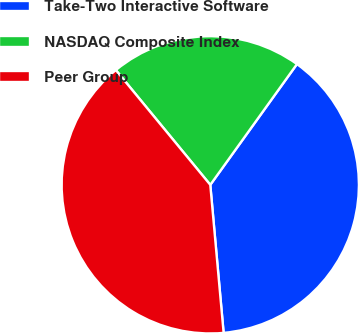Convert chart to OTSL. <chart><loc_0><loc_0><loc_500><loc_500><pie_chart><fcel>Take-Two Interactive Software<fcel>NASDAQ Composite Index<fcel>Peer Group<nl><fcel>38.66%<fcel>20.87%<fcel>40.47%<nl></chart> 